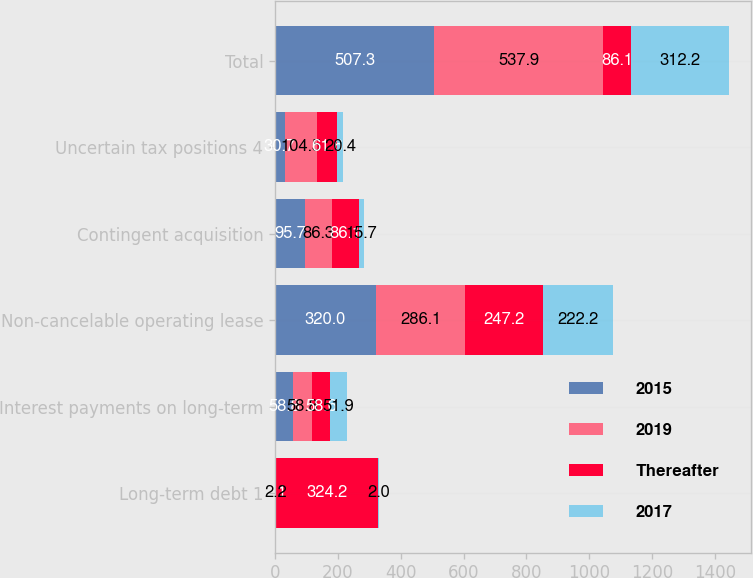Convert chart. <chart><loc_0><loc_0><loc_500><loc_500><stacked_bar_chart><ecel><fcel>Long-term debt 1<fcel>Interest payments on long-term<fcel>Non-cancelable operating lease<fcel>Contingent acquisition<fcel>Uncertain tax positions 4<fcel>Total<nl><fcel>2015<fcel>2.1<fcel>58.8<fcel>320<fcel>95.7<fcel>30.7<fcel>507.3<nl><fcel>2019<fcel>2.2<fcel>58.8<fcel>286.1<fcel>86.3<fcel>104.5<fcel>537.9<nl><fcel>Thereafter<fcel>324.2<fcel>58.6<fcel>247.2<fcel>86.1<fcel>61.6<fcel>86.1<nl><fcel>2017<fcel>2<fcel>51.9<fcel>222.2<fcel>15.7<fcel>20.4<fcel>312.2<nl></chart> 